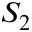Convert formula to latex. <formula><loc_0><loc_0><loc_500><loc_500>S _ { 2 }</formula> 